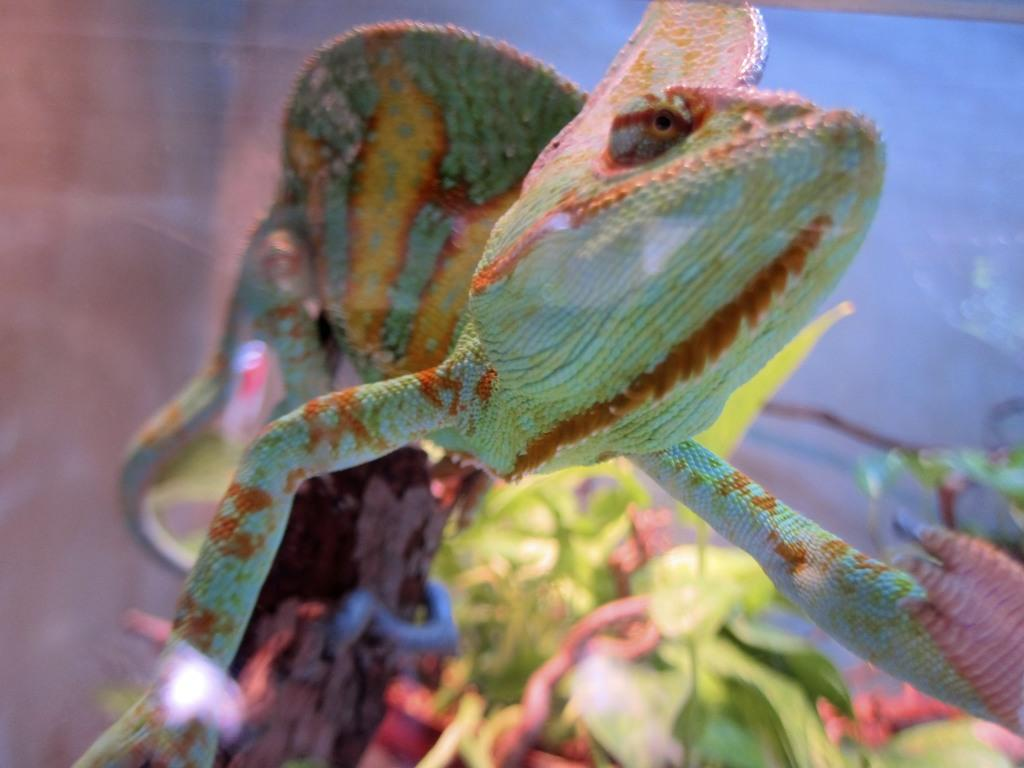What type of living creature is present in the image? There is an animal in the image. What type of stranger can be seen paying attention to the animal's observation in the image? There is no stranger present in the image, and the animal's observation cannot be determined from the provided fact. 